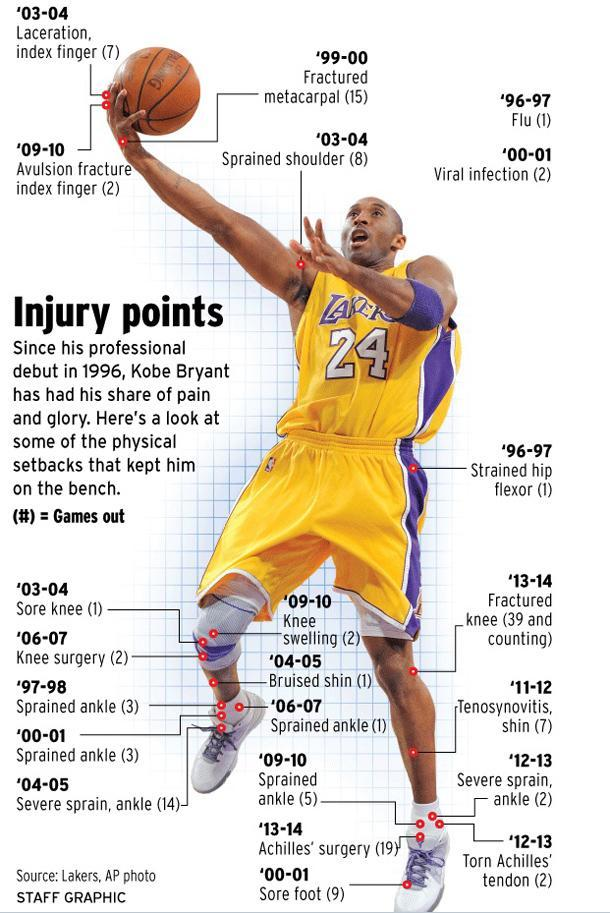What is the jersey number?
Answer the question with a short phrase. 24 How many surgeries did he have in total? 21 How many times did he have a "sprained ankle" ( not severe)? 12 What are the surgeries he had undergone? Knee surgery, Achilles Surgery How many times did he have a "severe"  sprain in the ankle? 16 